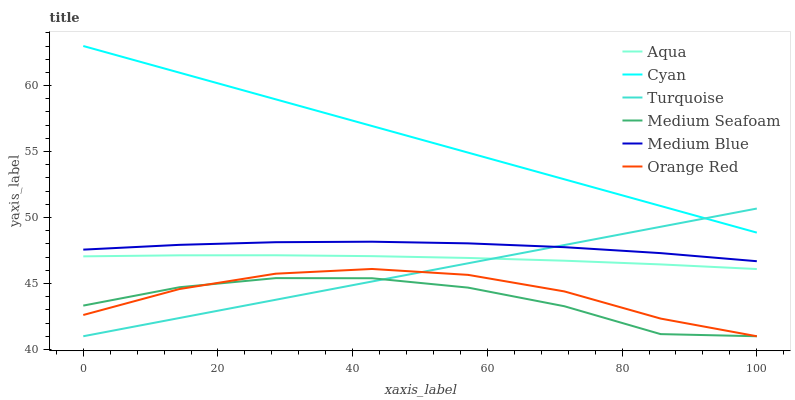Does Medium Seafoam have the minimum area under the curve?
Answer yes or no. Yes. Does Cyan have the maximum area under the curve?
Answer yes or no. Yes. Does Aqua have the minimum area under the curve?
Answer yes or no. No. Does Aqua have the maximum area under the curve?
Answer yes or no. No. Is Cyan the smoothest?
Answer yes or no. Yes. Is Medium Seafoam the roughest?
Answer yes or no. Yes. Is Aqua the smoothest?
Answer yes or no. No. Is Aqua the roughest?
Answer yes or no. No. Does Turquoise have the lowest value?
Answer yes or no. Yes. Does Aqua have the lowest value?
Answer yes or no. No. Does Cyan have the highest value?
Answer yes or no. Yes. Does Aqua have the highest value?
Answer yes or no. No. Is Orange Red less than Medium Blue?
Answer yes or no. Yes. Is Cyan greater than Medium Seafoam?
Answer yes or no. Yes. Does Turquoise intersect Medium Seafoam?
Answer yes or no. Yes. Is Turquoise less than Medium Seafoam?
Answer yes or no. No. Is Turquoise greater than Medium Seafoam?
Answer yes or no. No. Does Orange Red intersect Medium Blue?
Answer yes or no. No. 